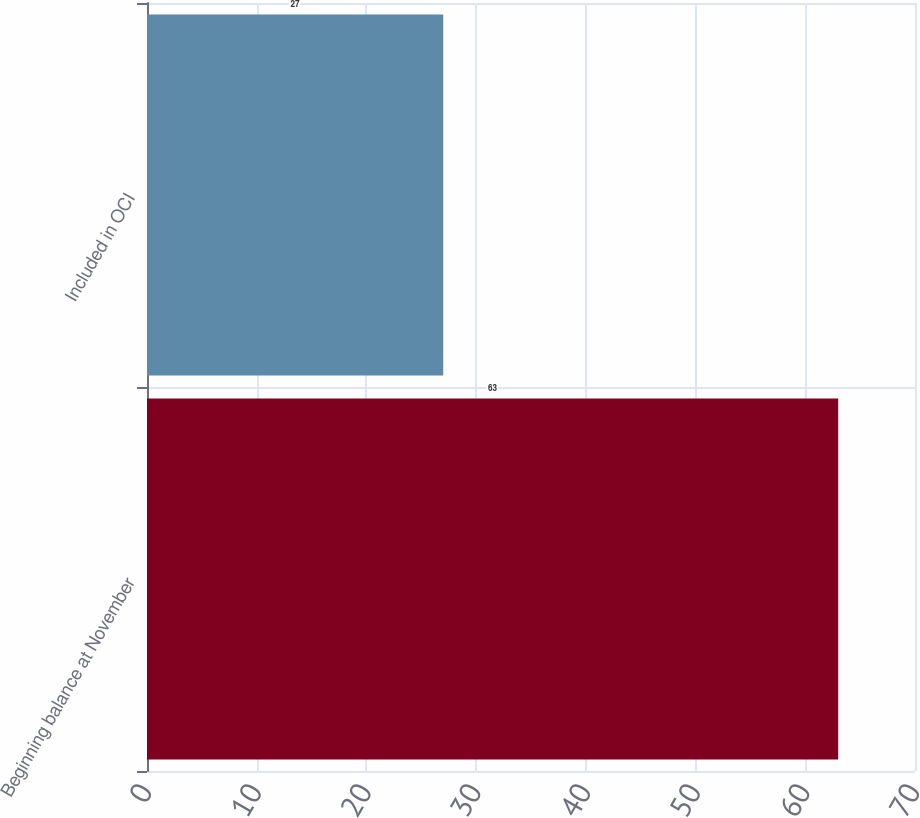<chart> <loc_0><loc_0><loc_500><loc_500><bar_chart><fcel>Beginning balance at November<fcel>Included in OCI<nl><fcel>63<fcel>27<nl></chart> 